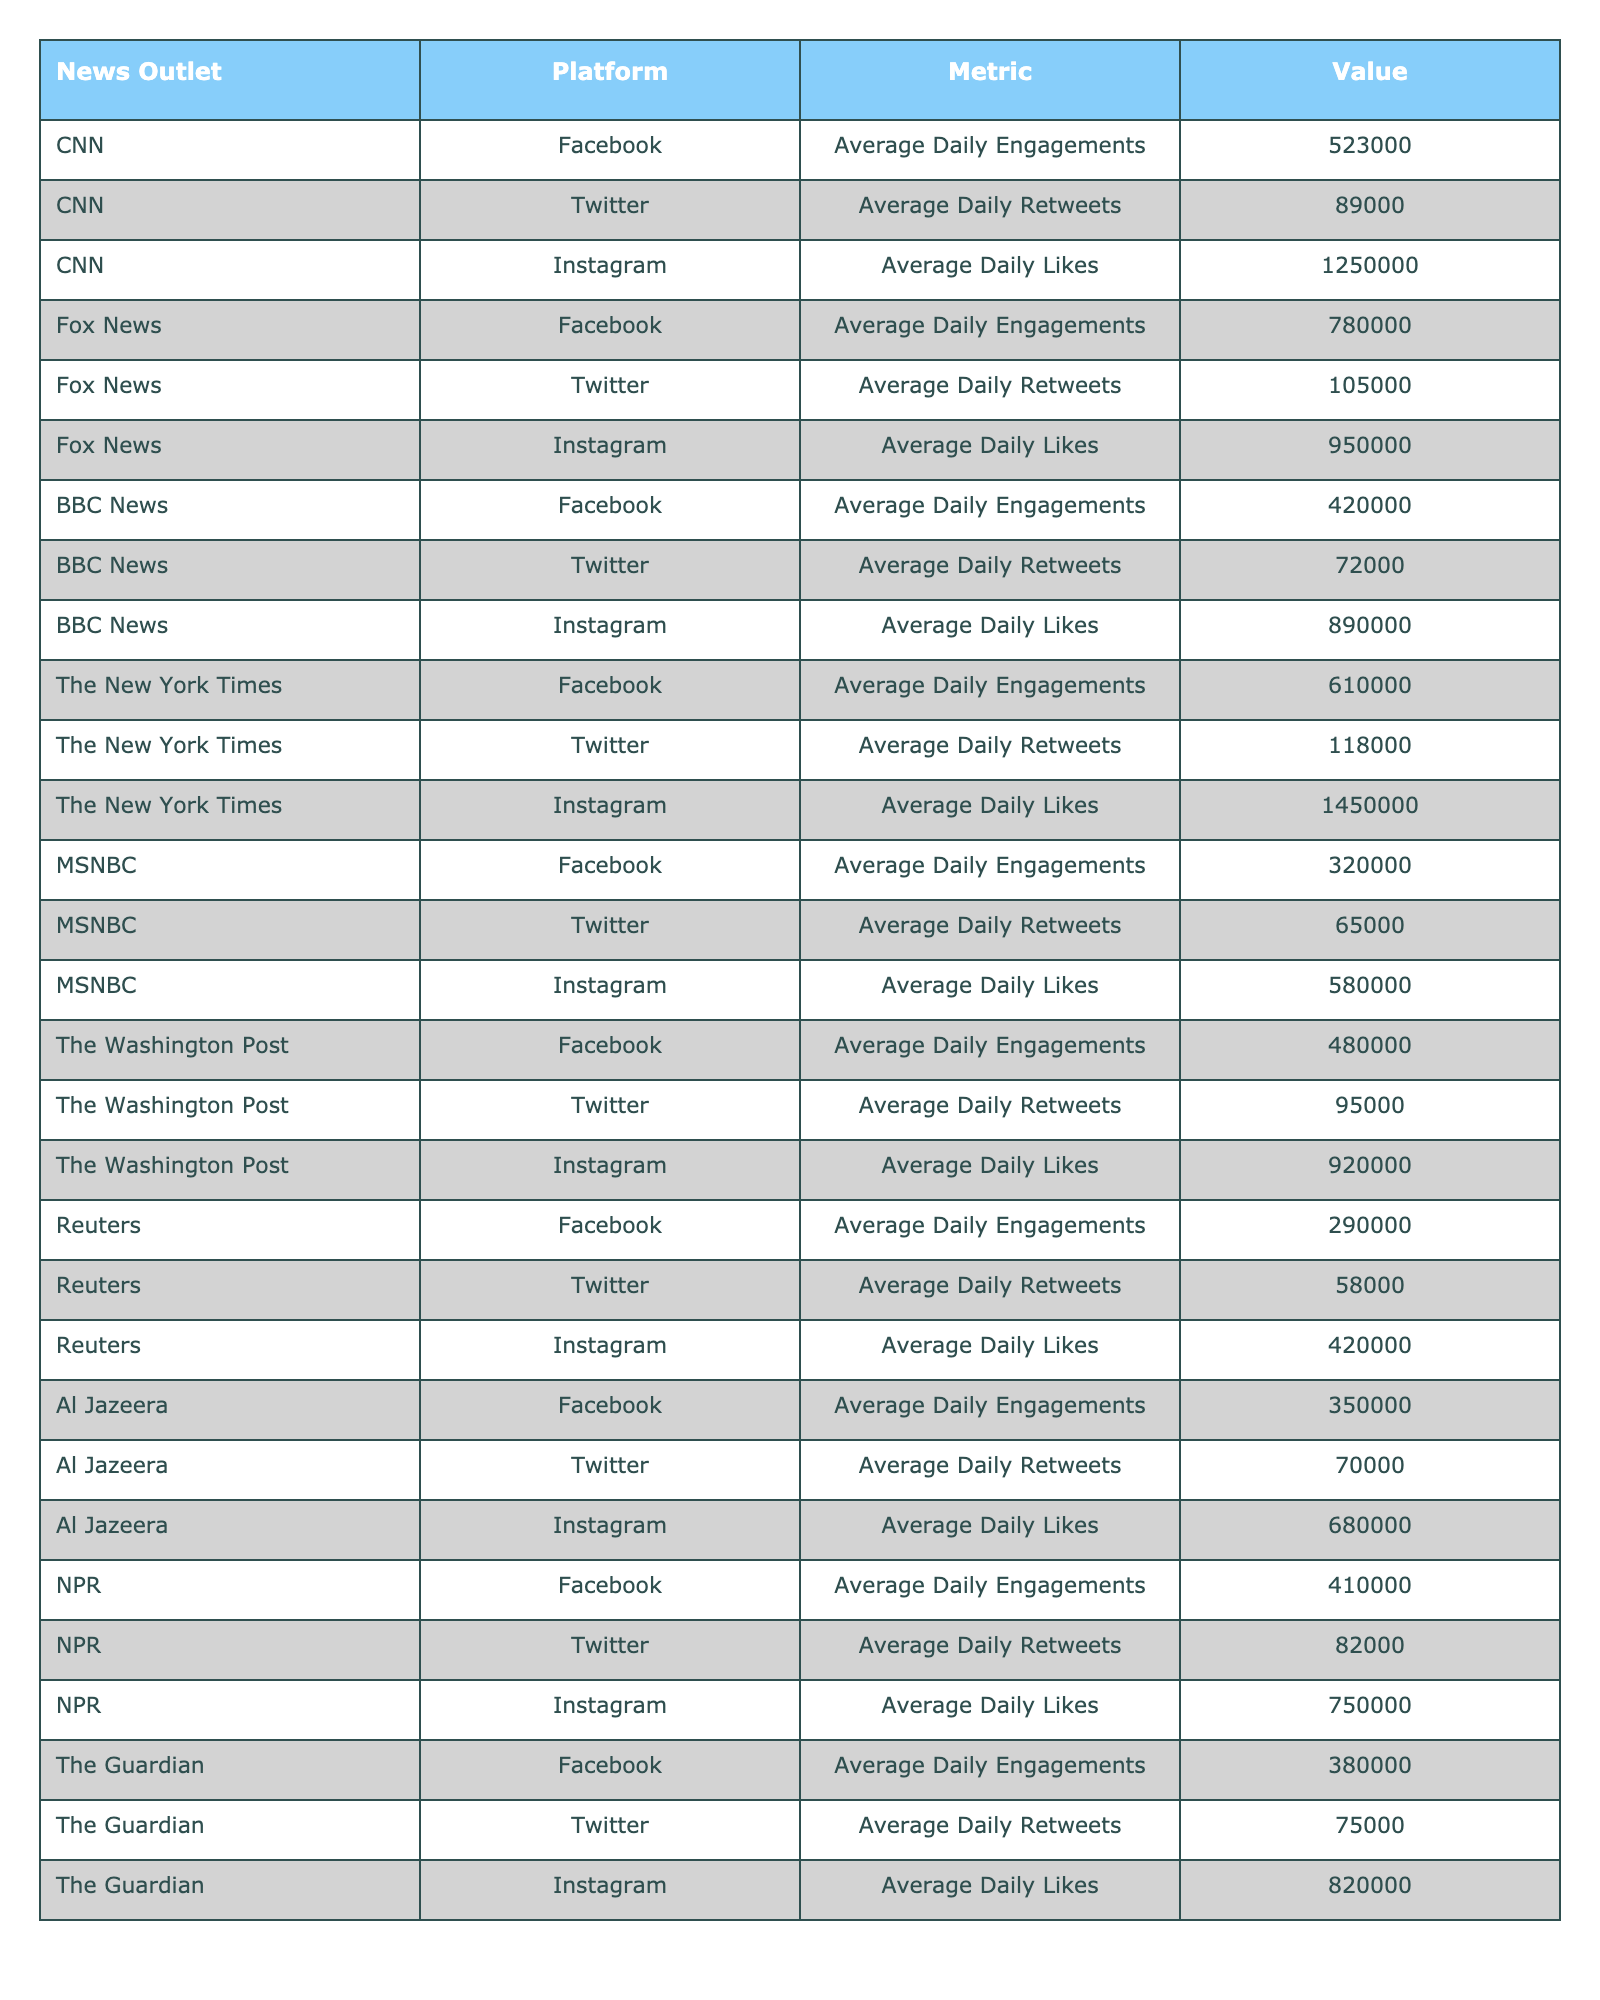What is the average daily engagement on Facebook for Fox News? The table shows that Fox News has an average daily engagement of 780,000 on Facebook.
Answer: 780,000 Which news outlet has the highest average daily likes on Instagram? From the table, The New York Times has the highest average daily likes on Instagram at 1,450,000.
Answer: The New York Times How many average daily retweets does CNN have on Twitter? CNN's average daily retweets on Twitter is listed as 89,000 in the table.
Answer: 89,000 What is the difference in average daily engagements on Facebook between CNN and The Washington Post? CNN has 523,000 average daily engagements, and The Washington Post has 480,000. The difference is 523,000 - 480,000 = 43,000.
Answer: 43,000 Which platform has the highest overall engagement metric for BBC News? The table lists BBC News with the following metrics: Facebook engagement at 420,000, Twitter retweets at 72,000, and Instagram likes at 890,000. The highest metric is Instagram likes at 890,000.
Answer: Instagram What is the total number of average daily retweets for all news outlets listed? The average daily retweets for the outlets are: CNN (89,000), Fox News (105,000), BBC News (72,000), The New York Times (118,000), MSNBC (65,000), The Washington Post (95,000), Reuters (58,000), Al Jazeera (70,000), NPR (82,000), and The Guardian (75,000). Summing these gives: 89,000 + 105,000 + 72,000 + 118,000 + 65,000 + 95,000 + 58,000 + 70,000 + 82,000 + 75,000 =  929,000.
Answer: 929,000 Is Al Jazeera’s average daily engagement on Facebook greater than NPR’s? Al Jazeera has 350,000 average daily engagements on Facebook, while NPR has 410,000. Thus, Al Jazeera's engagement is less than NPR's.
Answer: No What are the average daily likes of Instagram for The Guardian? The table indicates that The Guardian has an average daily likes count of 820,000 on Instagram.
Answer: 820,000 Which news outlet has the least average daily engagement on Facebook? Looking at the Facebook engagements, Reuters has the least at 290,000.
Answer: Reuters 